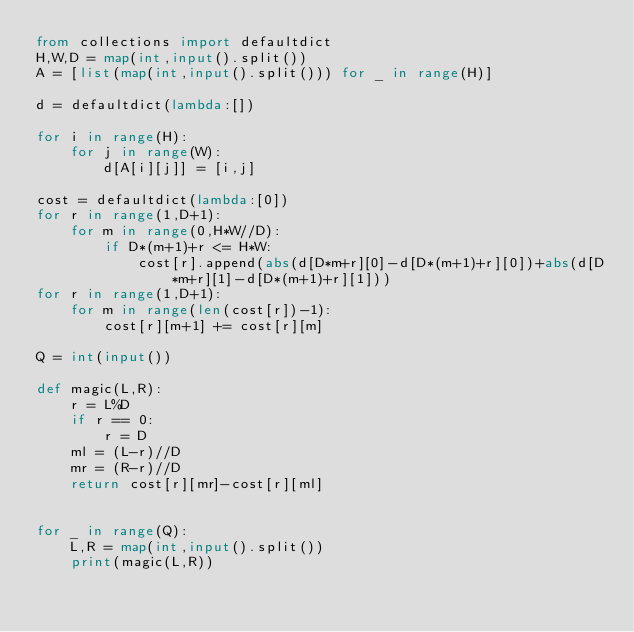<code> <loc_0><loc_0><loc_500><loc_500><_Python_>from collections import defaultdict
H,W,D = map(int,input().split())
A = [list(map(int,input().split())) for _ in range(H)]

d = defaultdict(lambda:[])

for i in range(H):
    for j in range(W):
        d[A[i][j]] = [i,j]

cost = defaultdict(lambda:[0])
for r in range(1,D+1):
    for m in range(0,H*W//D):
        if D*(m+1)+r <= H*W:
            cost[r].append(abs(d[D*m+r][0]-d[D*(m+1)+r][0])+abs(d[D*m+r][1]-d[D*(m+1)+r][1]))
for r in range(1,D+1):
    for m in range(len(cost[r])-1):
        cost[r][m+1] += cost[r][m]

Q = int(input())

def magic(L,R):
    r = L%D
    if r == 0:
        r = D
    ml = (L-r)//D
    mr = (R-r)//D
    return cost[r][mr]-cost[r][ml]


for _ in range(Q):
    L,R = map(int,input().split())
    print(magic(L,R))</code> 